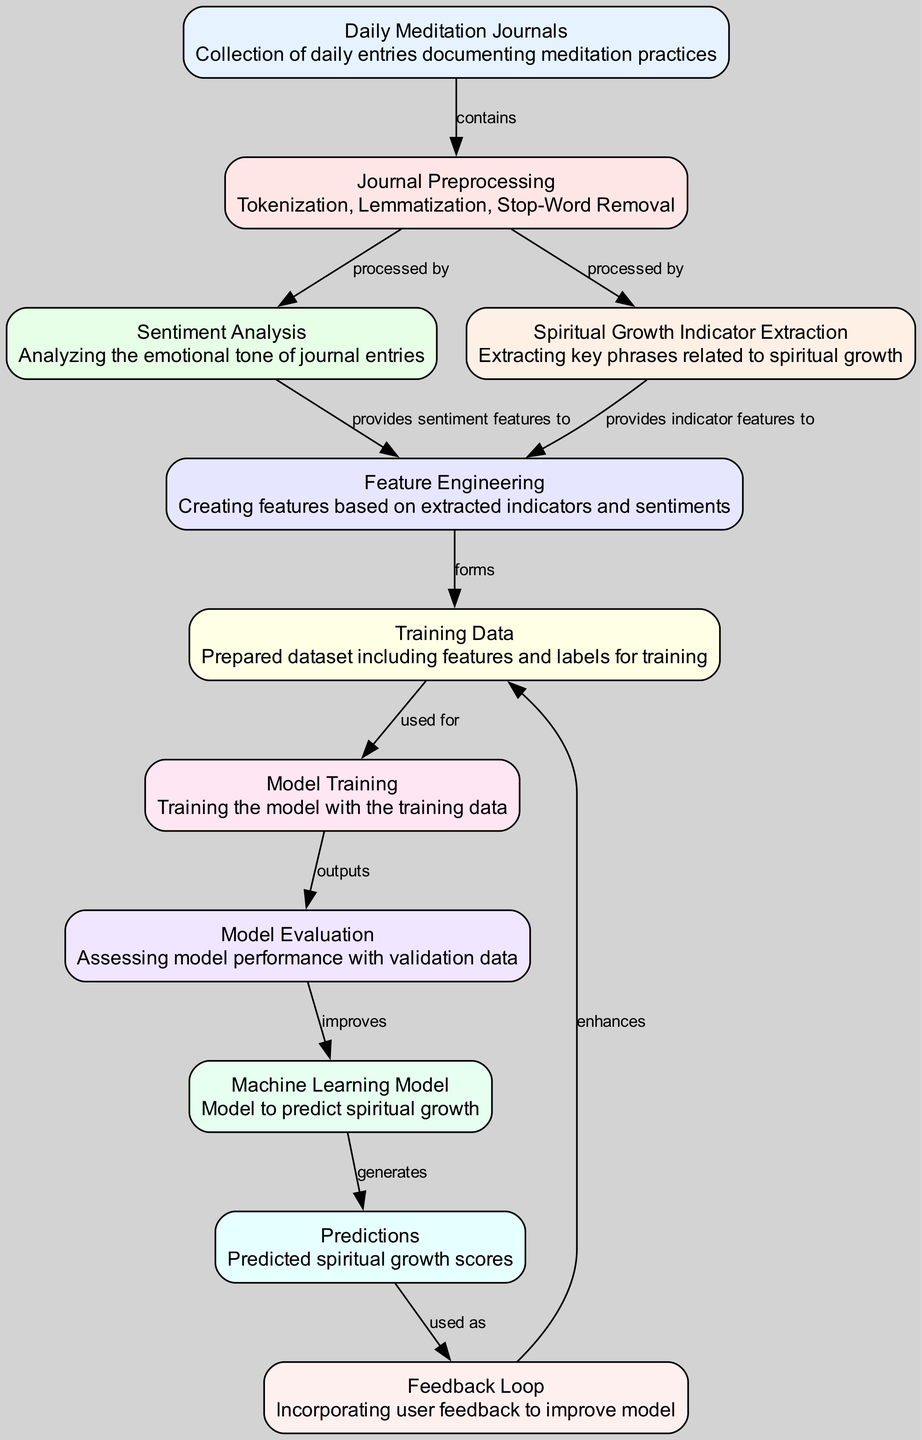What is the starting point of the process? The starting point is "Daily Meditation Journals," which contains a collection of daily entries documenting meditation practices.
Answer: Daily Meditation Journals How many nodes are present in the diagram? There are a total of 11 nodes representing various steps in the predictive analysis process.
Answer: 11 What type of analysis follows the "Journal Preprocessing"? After "Journal Preprocessing," the next steps are "Sentiment Analysis" and "Spiritual Growth Indicator Extraction," both processed from it.
Answer: Sentiment Analysis and Spiritual Growth Indicator Extraction Which node generates the predictions? The node that generates the predictions is "Machine Learning Model," which takes input from the prior steps and outputs the predicted spiritual growth scores.
Answer: Machine Learning Model How does the feedback loop contribute to the model? The "Feedback Loop" incorporates user feedback, which helps enhance the "Training Data," thus improving the overall model continuously.
Answer: Enhances What is the relationship between "Model Evaluation" and "Machine Learning Model"? "Model Evaluation" assesses the performance of the "Machine Learning Model" by validating it with data, thus improving it.
Answer: Improves Which nodes provide features for "Feature Engineering"? The nodes "Sentiment Analysis" and "Spiritual Growth Indicator Extraction" both supply crucial features for the "Feature Engineering" step.
Answer: Sentiment Analysis and Spiritual Growth Indicator Extraction What type of data does the "Training Data" comprise? The "Training Data" consists of a prepared dataset that includes features derived from both sentiment and indicators along with corresponding labels for model training.
Answer: Features and Labels 